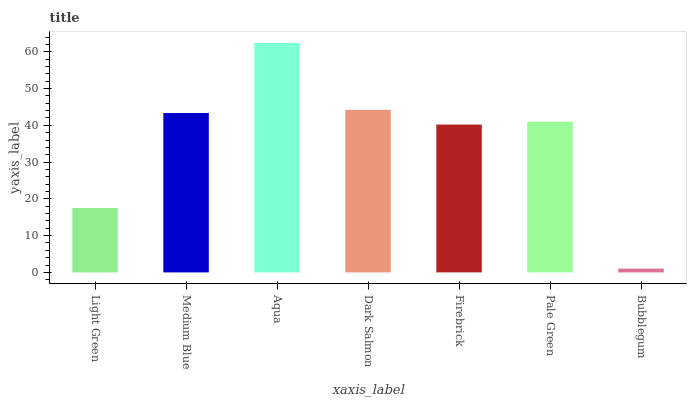Is Medium Blue the minimum?
Answer yes or no. No. Is Medium Blue the maximum?
Answer yes or no. No. Is Medium Blue greater than Light Green?
Answer yes or no. Yes. Is Light Green less than Medium Blue?
Answer yes or no. Yes. Is Light Green greater than Medium Blue?
Answer yes or no. No. Is Medium Blue less than Light Green?
Answer yes or no. No. Is Pale Green the high median?
Answer yes or no. Yes. Is Pale Green the low median?
Answer yes or no. Yes. Is Bubblegum the high median?
Answer yes or no. No. Is Medium Blue the low median?
Answer yes or no. No. 